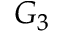Convert formula to latex. <formula><loc_0><loc_0><loc_500><loc_500>G _ { 3 }</formula> 